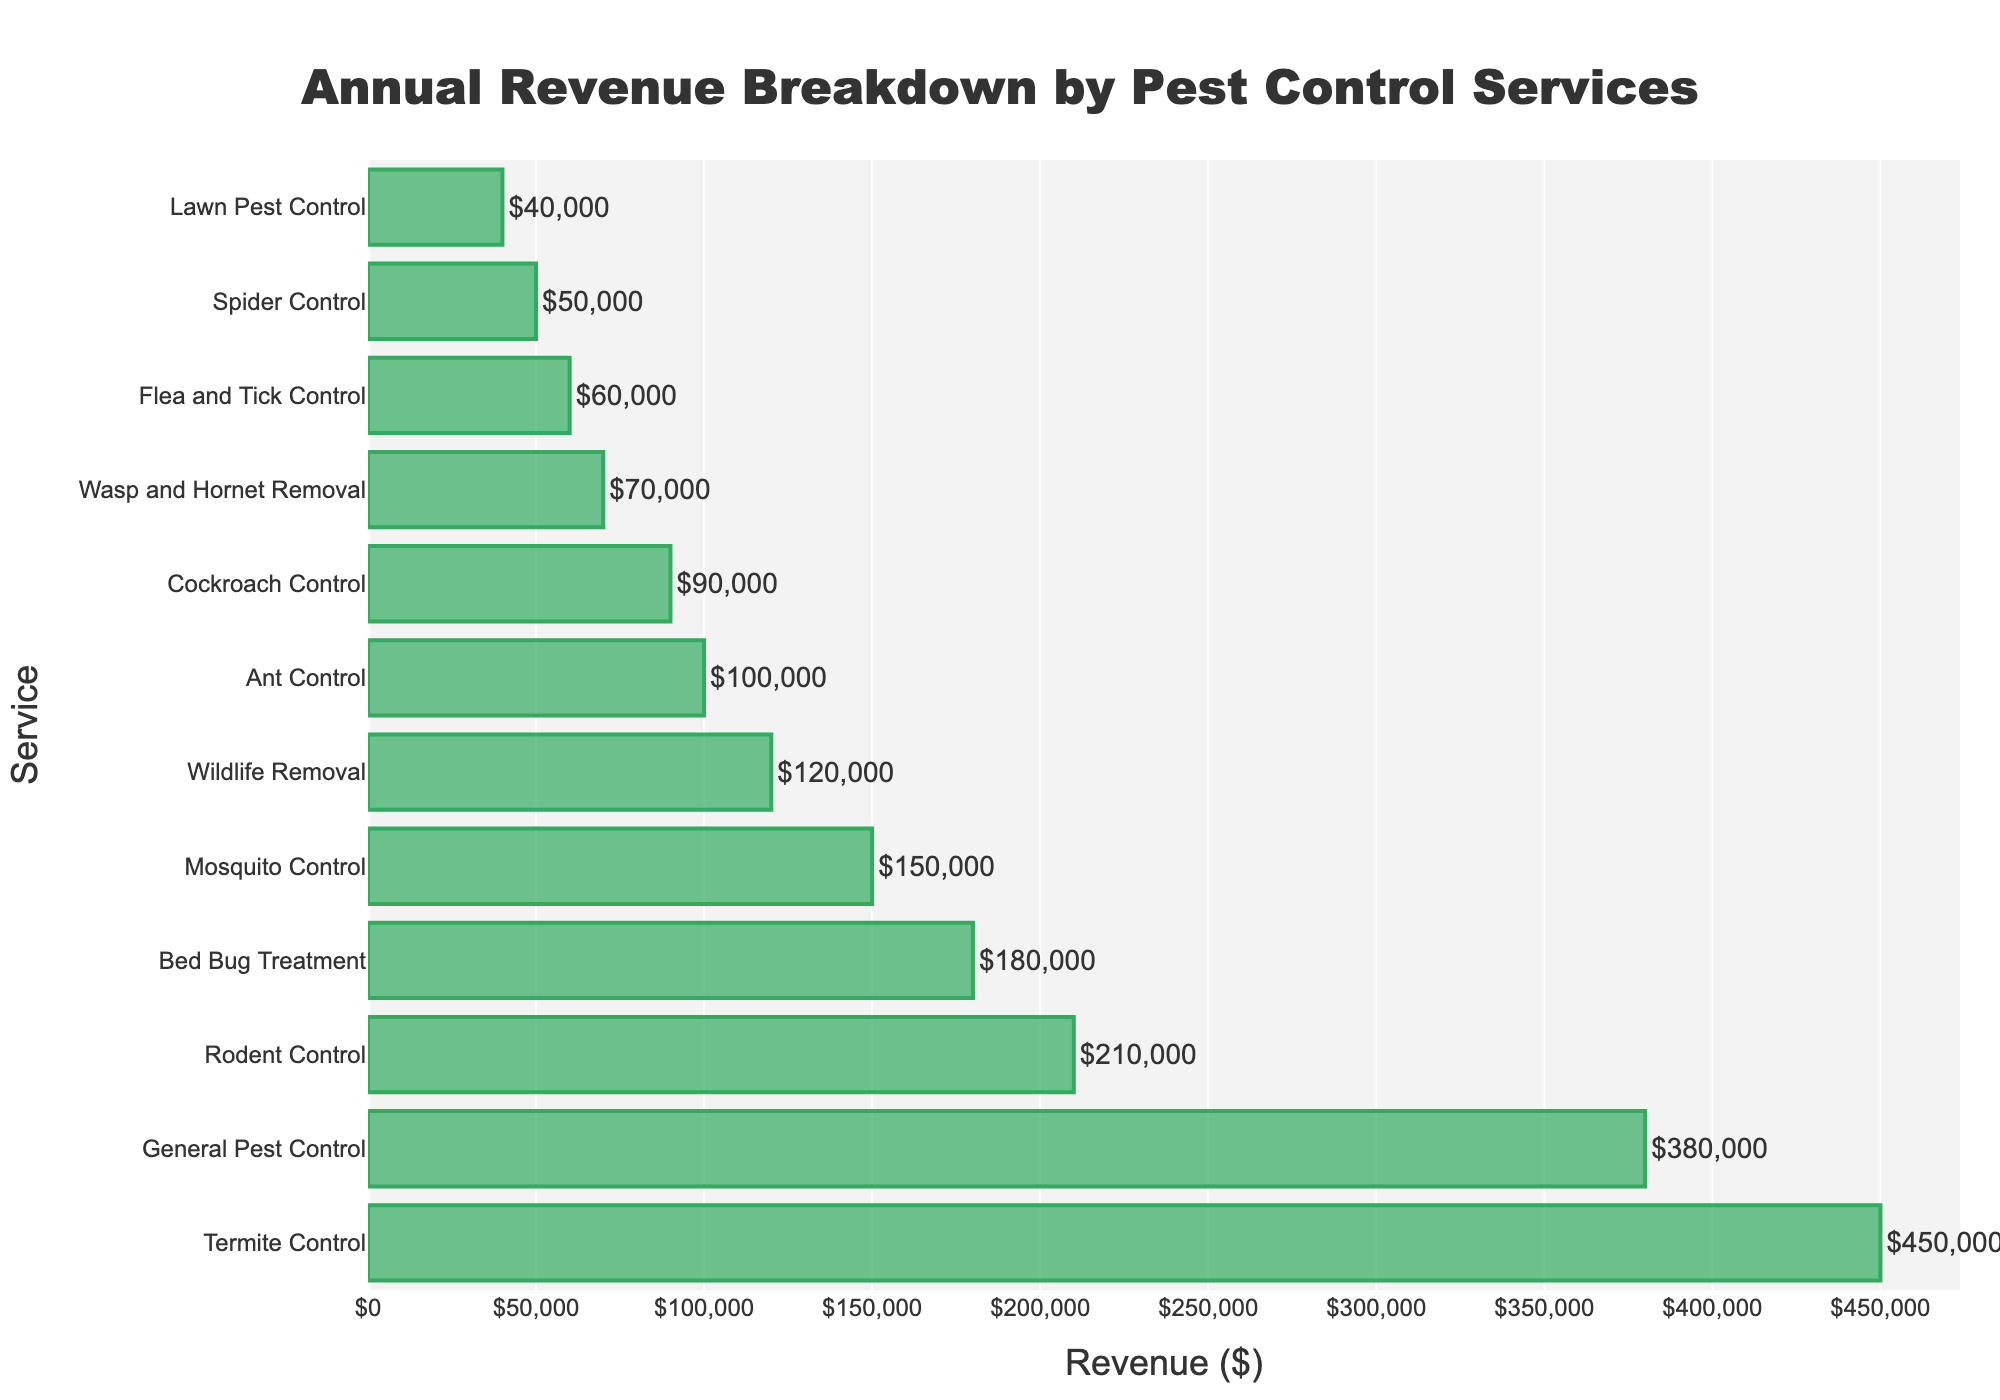What service generates the highest annual revenue? The bar representing Termite Control is the longest, indicating the highest revenue among all services.
Answer: Termite Control Which two services combined generate a revenue close to the total of Termite Control? The revenues of General Pest Control ($380,000) and Rodent Control ($210,000) add up to $590,000, which is close but more than Termite Control's $450,000. Instead, General Pest Control ($380,000) and Bed Bug Treatment ($180,000) total $560,000. Another good combination could be Rodent Control ($210,000) and Bed Bug Treatment ($180,000), which total $390,000, closer but less. The combined closest two are General Pest Control and Rodent Control for $590,000.
Answer: General Pest Control and Rodent Control How much more revenue does General Pest Control generate compared to Mosquito Control? The revenue of General Pest Control ($380,000) minus the revenue of Mosquito Control ($150,000) gives the difference. $380,000 - $150,000 = $230,000
Answer: $230,000 What is the average revenue for Wildlife Removal, Flea and Tick Control, and Lawn Pest Control? Add the revenues of Wildlife Removal ($120,000), Flea and Tick Control ($60,000), and Lawn Pest Control ($40,000) and then divide by the number of services (3). (120,000 + 60,000 + 40,000) = $220,000, $220,000 / 3 = $73,333
Answer: $73,333 Which service has the least annual revenue and what is the value? The shortest bar represents Lawn Pest Control, indicating it has the least revenue. The revenue is $40,000.
Answer: Lawn Pest Control, $40,000 How does the revenue of Bed Bug Treatment compare to Cockroach Control? The revenue for Bed Bug Treatment ($180,000) is greater than Cockroach Control ($90,000).
Answer: Bed Bug Treatment generates more What is the combined revenue of all services generating less than $100,000 each? Add the revenues of Cockroach Control ($90,000), Wasp and Hornet Removal ($70,000), Flea and Tick Control ($60,000), Spider Control ($50,000), and Lawn Pest Control ($40,000). The combined revenue is (90,000 + 70,000 + 60,000 + 50,000 + 40,000) = $310,000
Answer: $310,000 Which services generate revenue greater than $200,000 and what are their collective revenues? Termite Control ($450,000), General Pest Control ($380,000), and Rodent Control ($210,000) each generate more than $200,000. Sum their revenues: (450,000 + 380,000 + 210,000) = $1,040,000
Answer: $1,040,000 How much more revenue does Termite Control generate compared to Ant Control, Cockroach Control, and Spider Control combined? First, sum the revenues of Ant Control ($100,000), Cockroach Control ($90,000), and Spider Control ($50,000). Then, subtract that from Termite Control's revenue ($450,000). (100,000 + 90,000 + 50,000) = $240,000, $450,000 - $240,000 = $210,000
Answer: $210,000 